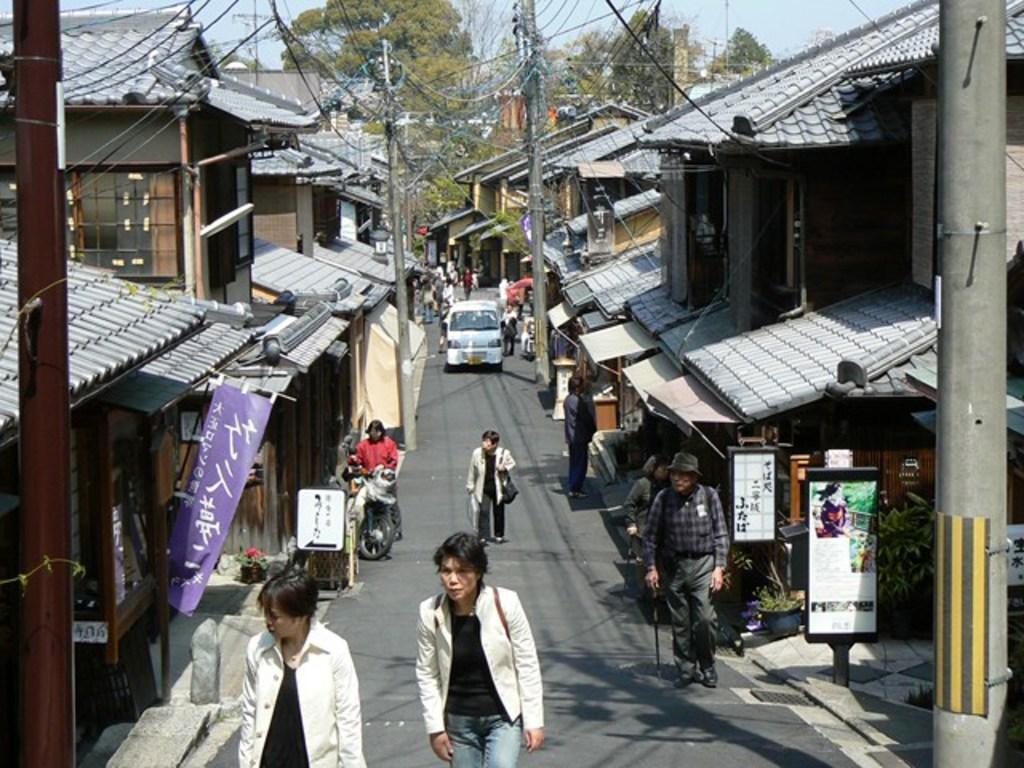Describe this image in one or two sentences. At the bottom of the image on the road there are few people walking and also there are few vehicles. There are footpaths with name boards and poles with posters. And also there are buildings with walls, windows and roofs. There are electrical poles with wires. In the background there are trees and also there is sky. 